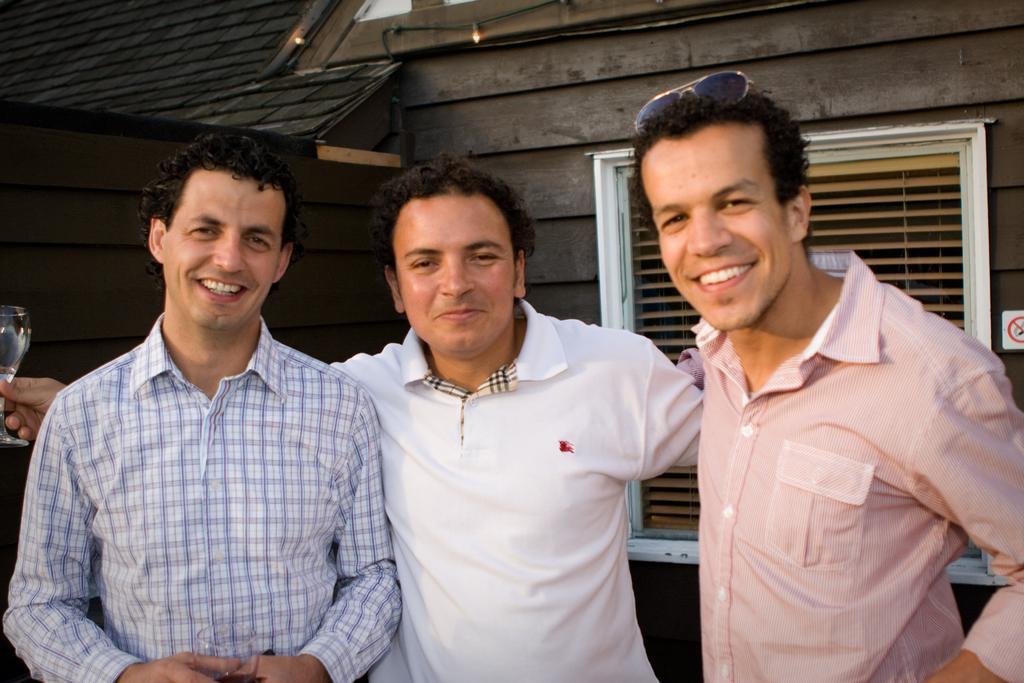How would you summarize this image in a sentence or two? In this picture I can see three persons standing and smiling, a person holding a wine glass, there are lights, a board, and in the background there is a window shutter on the wall. 